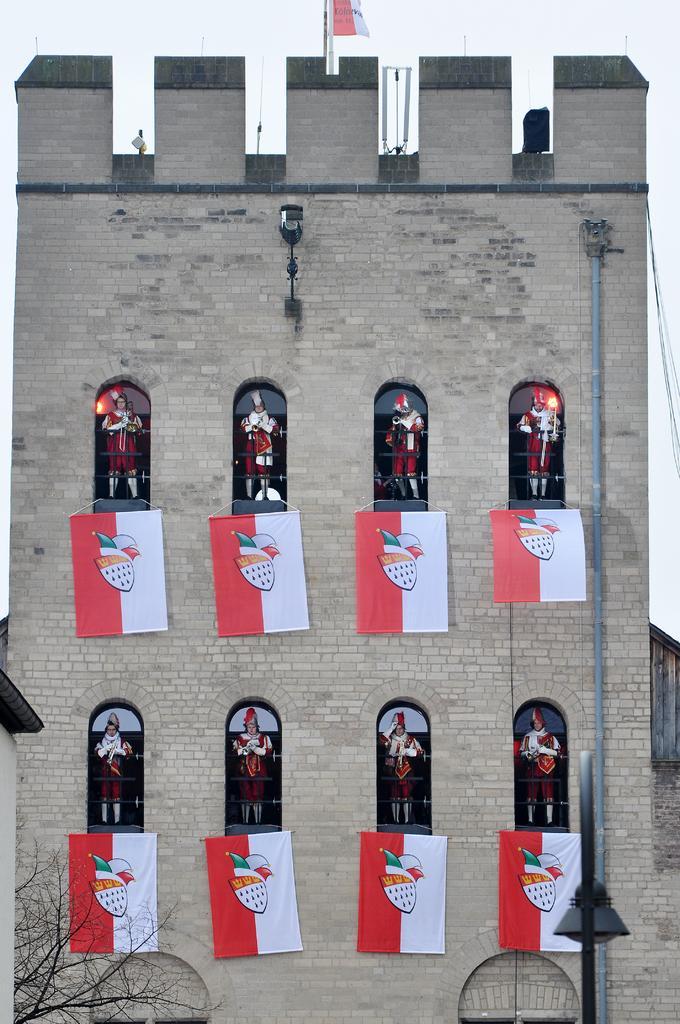How would you summarize this image in a sentence or two? In this image we can see the brick buildings, flags which are in red and white color and having logos on it. Here we can see persons standing near the windows, we can see light poles, tree and sky in the background. 